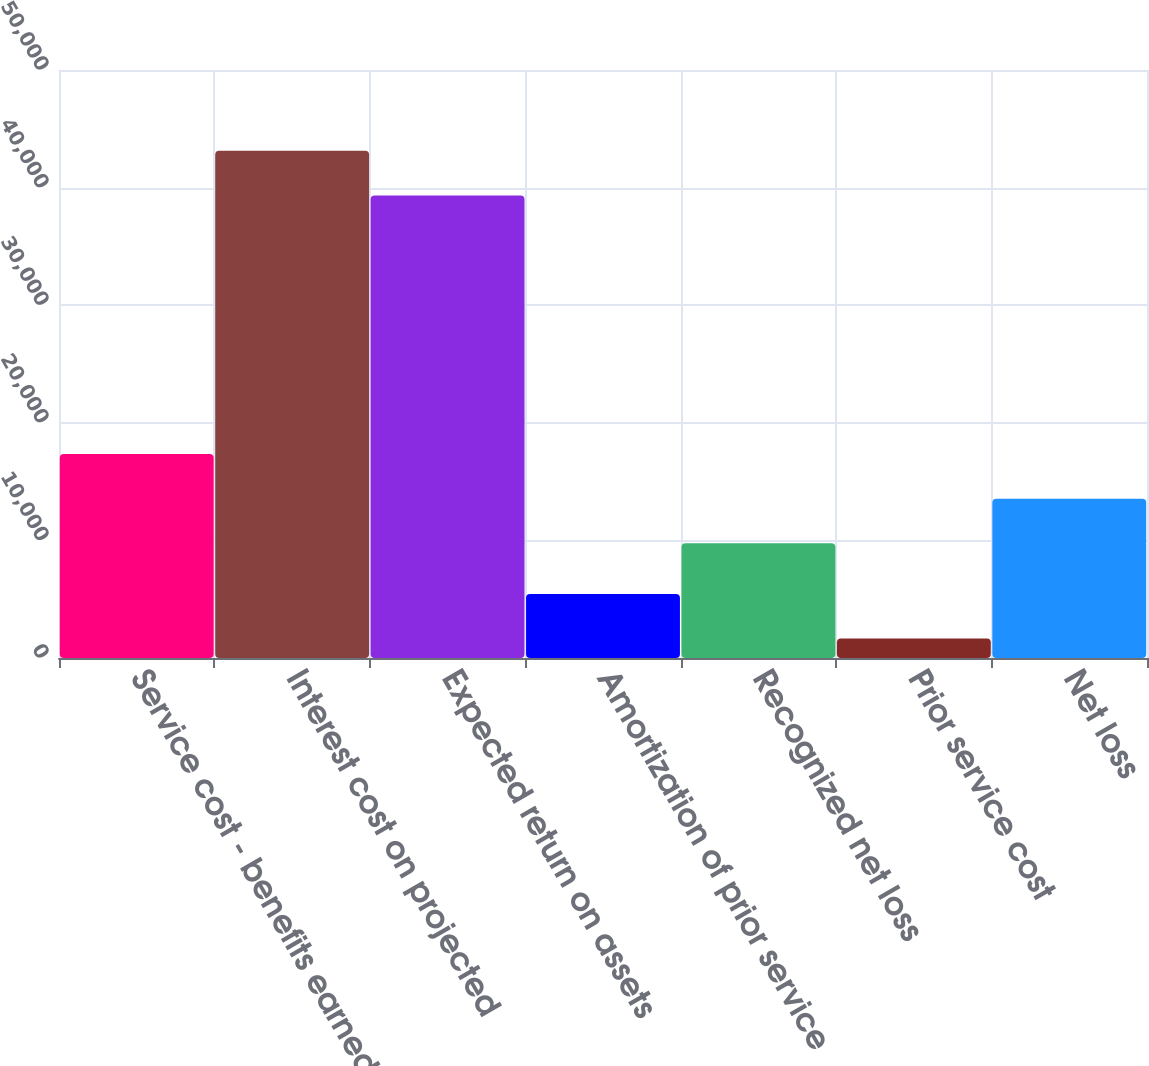<chart> <loc_0><loc_0><loc_500><loc_500><bar_chart><fcel>Service cost - benefits earned<fcel>Interest cost on projected<fcel>Expected return on assets<fcel>Amortization of prior service<fcel>Recognized net loss<fcel>Prior service cost<fcel>Net loss<nl><fcel>17351.2<fcel>43136.1<fcel>39335<fcel>5450.1<fcel>9749<fcel>1649<fcel>13550.1<nl></chart> 